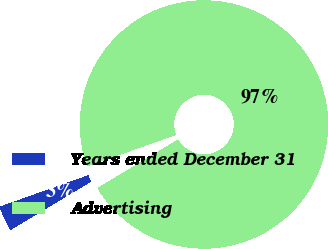<chart> <loc_0><loc_0><loc_500><loc_500><pie_chart><fcel>Years ended December 31<fcel>Advertising<nl><fcel>3.19%<fcel>96.81%<nl></chart> 